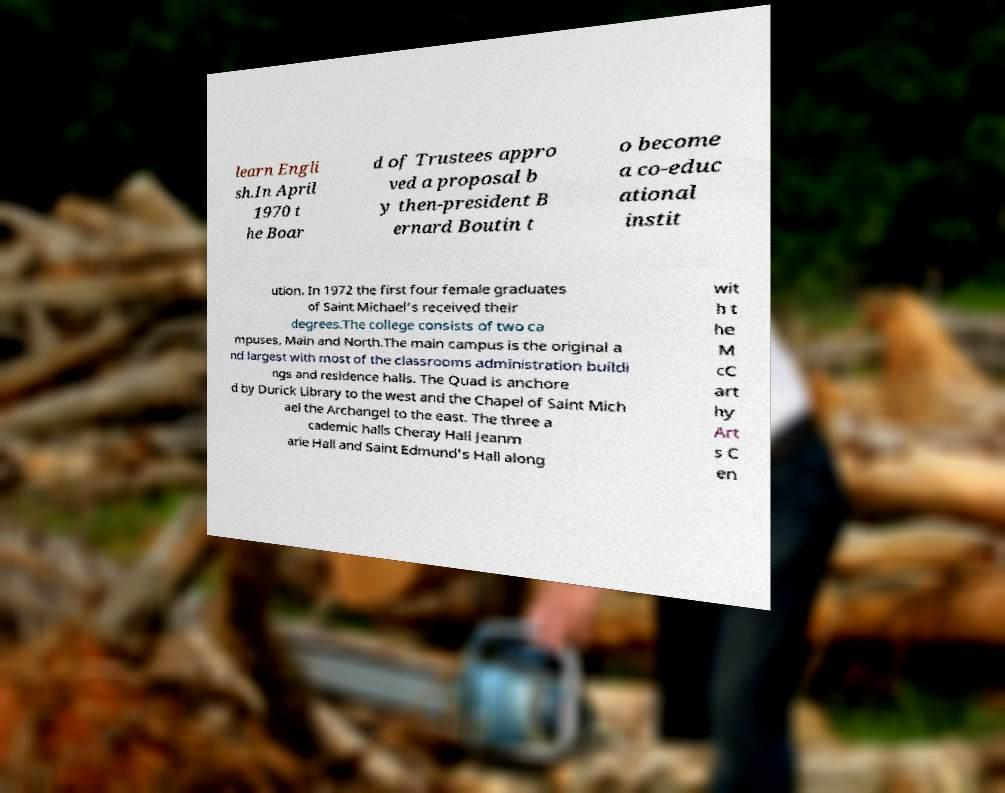Could you extract and type out the text from this image? learn Engli sh.In April 1970 t he Boar d of Trustees appro ved a proposal b y then-president B ernard Boutin t o become a co-educ ational instit ution. In 1972 the first four female graduates of Saint Michael's received their degrees.The college consists of two ca mpuses, Main and North.The main campus is the original a nd largest with most of the classrooms administration buildi ngs and residence halls. The Quad is anchore d by Durick Library to the west and the Chapel of Saint Mich ael the Archangel to the east. The three a cademic halls Cheray Hall Jeanm arie Hall and Saint Edmund's Hall along wit h t he M cC art hy Art s C en 